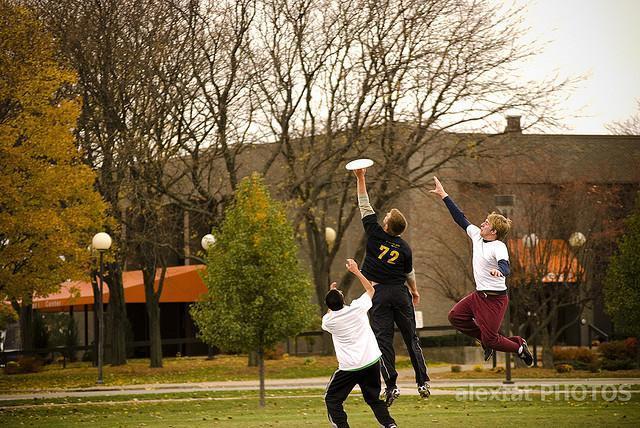How many people are in the photo?
Give a very brief answer. 3. 